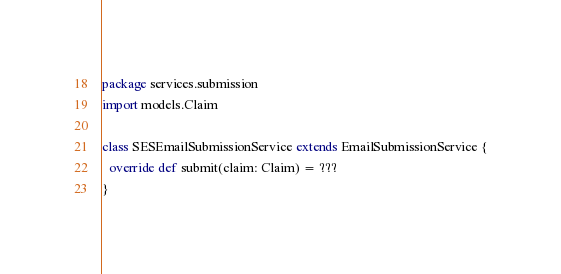Convert code to text. <code><loc_0><loc_0><loc_500><loc_500><_Scala_>package services.submission
import models.Claim

class SESEmailSubmissionService extends EmailSubmissionService {
  override def submit(claim: Claim) = ???
}
</code> 